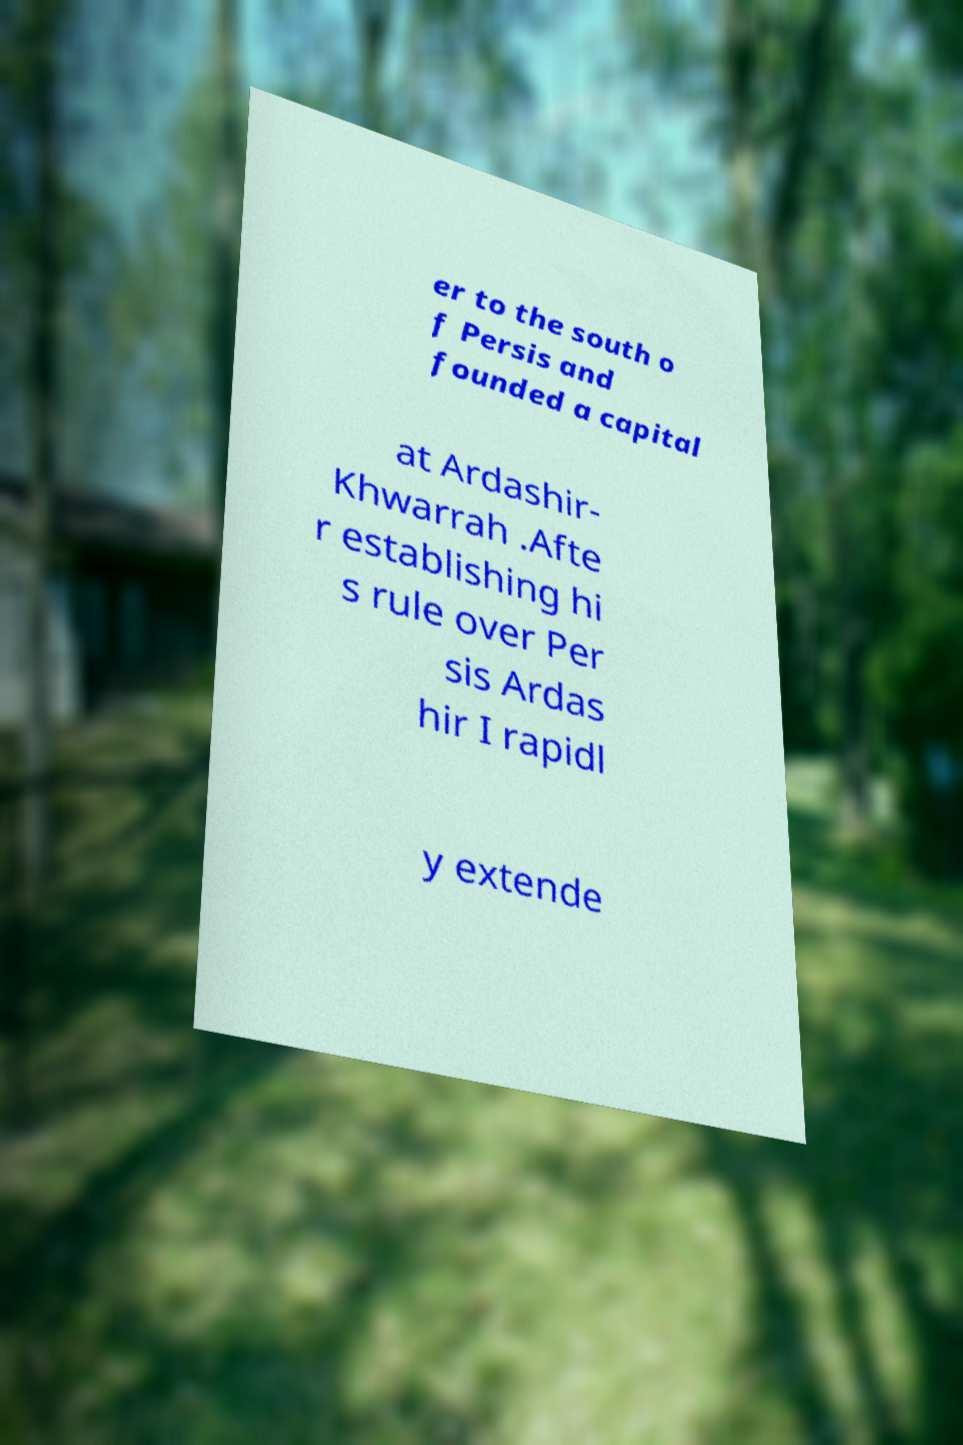There's text embedded in this image that I need extracted. Can you transcribe it verbatim? er to the south o f Persis and founded a capital at Ardashir- Khwarrah .Afte r establishing hi s rule over Per sis Ardas hir I rapidl y extende 